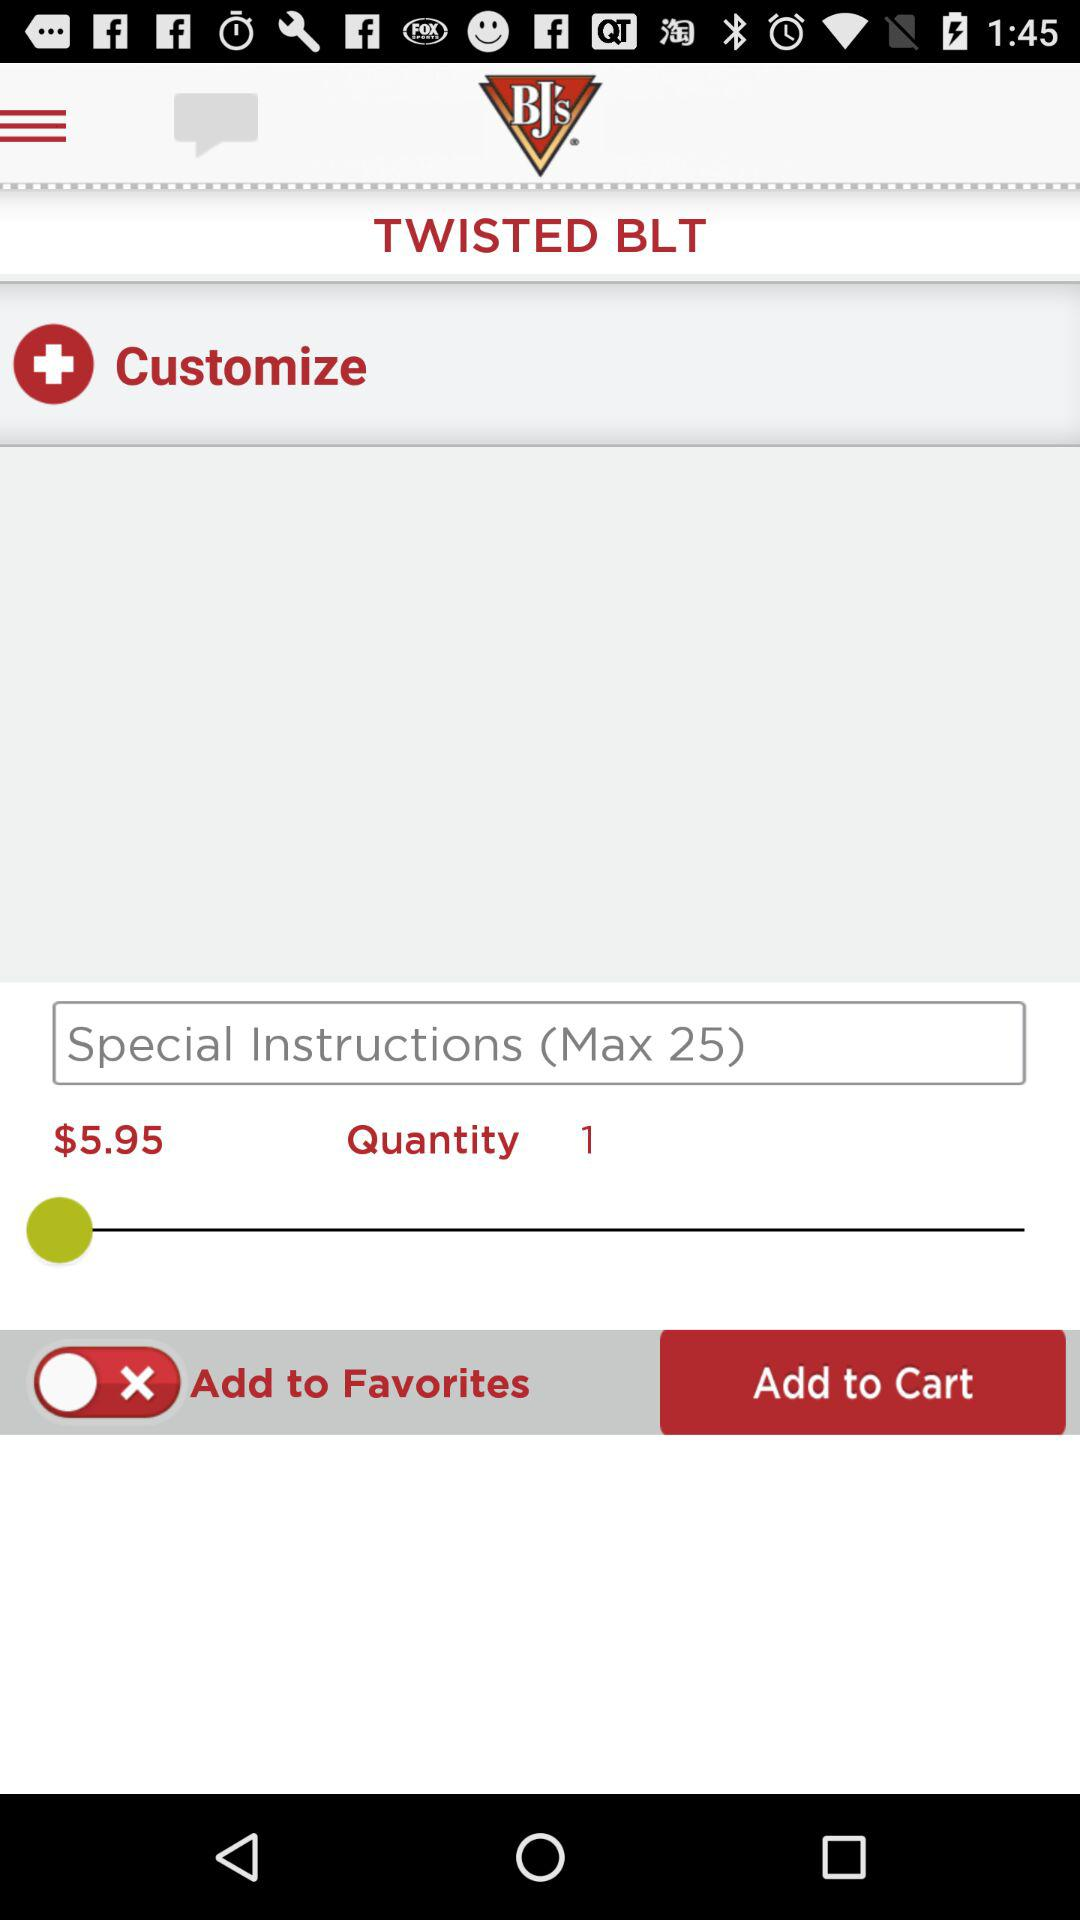Who is ordering the BLT?
When the provided information is insufficient, respond with <no answer>. <no answer> 